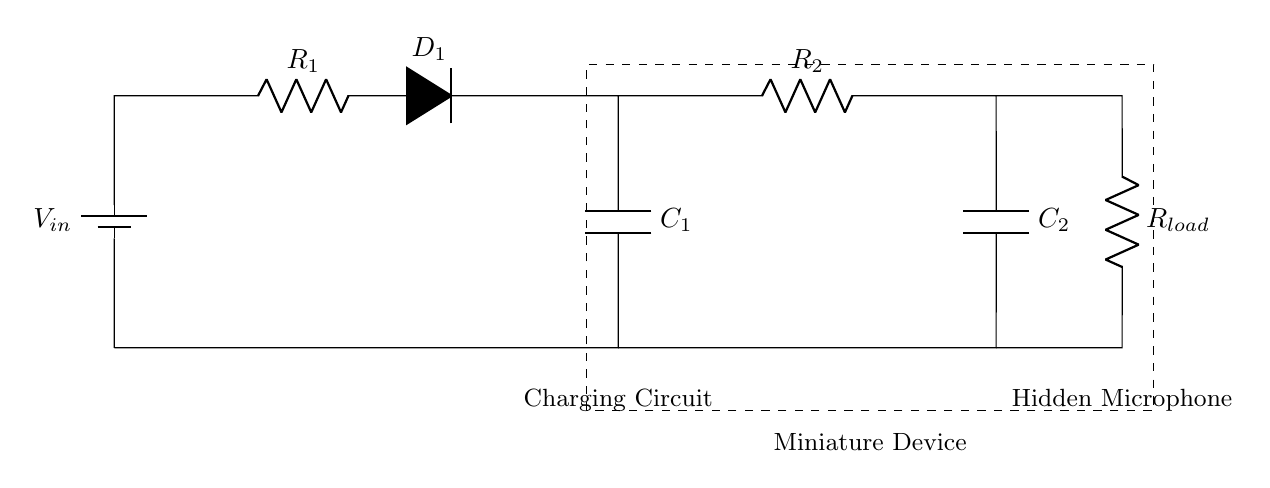What is the input voltage in this circuit? The input voltage is labeled as V_in on the diagram, indicating the source of electrical potential in the circuit.
Answer: V_in What component creates a barrier for current flow in one direction? The component labeled as D_1 is a diode, which allows current to flow in one direction while blocking it in the opposite direction.
Answer: D_1 Which component is responsible for storing energy in this circuit? The components C_1 and C_2, which are labeled as capacitors, are responsible for storing electrical energy in the circuit.
Answer: C_1, C_2 What is the relationship between R_1 and R_2 in this charging circuit? R_1 and R_2 are both resistors that influence the charging time of the capacitors C_1 and C_2; a higher resistance will slow down the charging time.
Answer: Resistance influence How do the resistors affect the charging rate of the capacitors? The resistors R_1 and R_2 limit the current flowing into the capacitors C_1 and C_2, thereby controlling how quickly they charge. Higher resistance leads to a longer charge time.
Answer: Limited charging rate Which component is directly connected to the hidden microphone? The component labeled as R_load is directly connected to the hidden microphone, indicating that it supplies or regulates the current flowing to the microphone.
Answer: R_load 